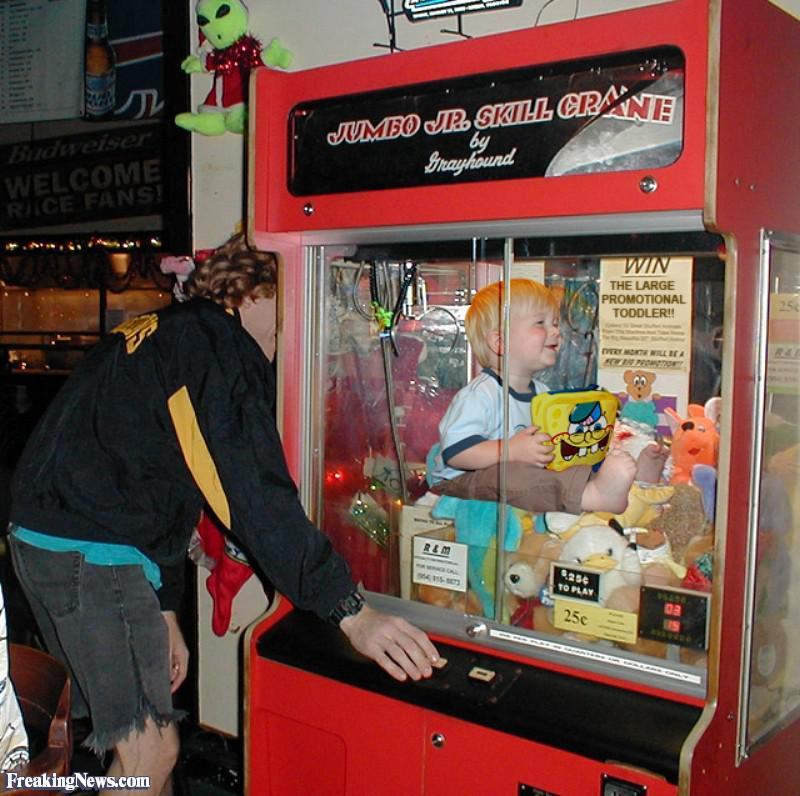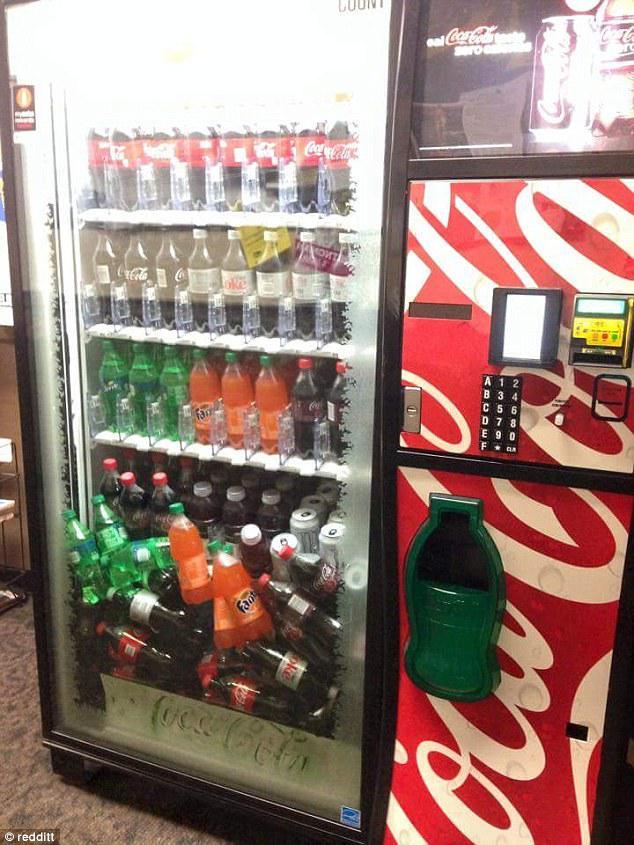The first image is the image on the left, the second image is the image on the right. Given the left and right images, does the statement "One image shows a vending machine front with one bottle at a diagonal, as if falling." hold true? Answer yes or no. No. The first image is the image on the left, the second image is the image on the right. Assess this claim about the two images: "At least one pack of peanut m&m's is in a vending machine in one of the images.". Correct or not? Answer yes or no. No. 